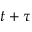Convert formula to latex. <formula><loc_0><loc_0><loc_500><loc_500>t + \tau</formula> 